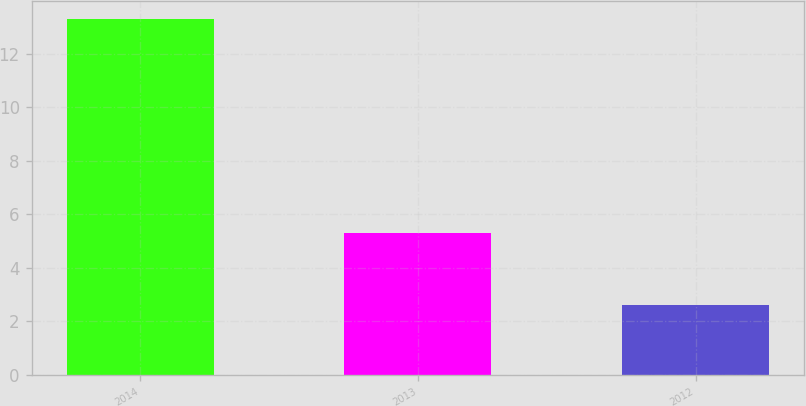Convert chart to OTSL. <chart><loc_0><loc_0><loc_500><loc_500><bar_chart><fcel>2014<fcel>2013<fcel>2012<nl><fcel>13.3<fcel>5.3<fcel>2.6<nl></chart> 